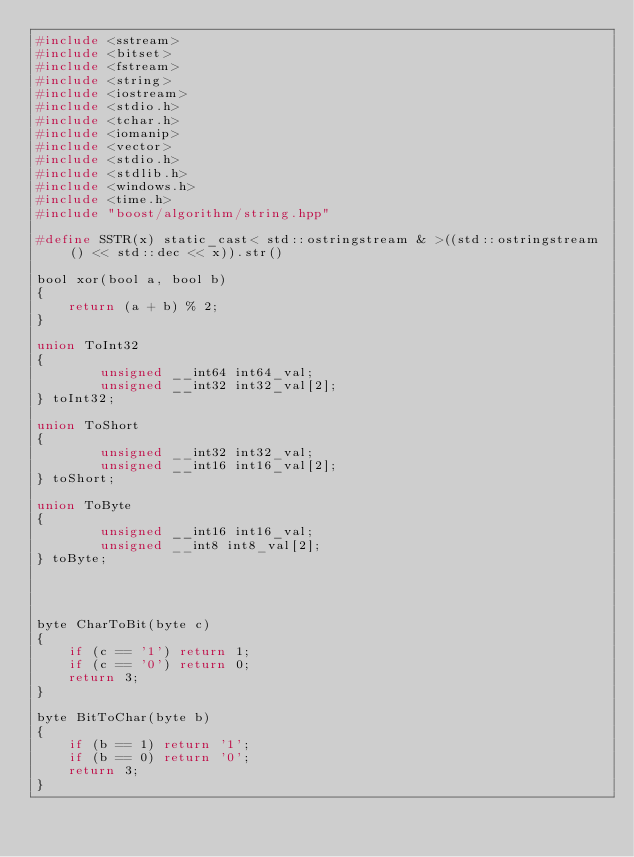<code> <loc_0><loc_0><loc_500><loc_500><_C_>#include <sstream>
#include <bitset>
#include <fstream>
#include <string>
#include <iostream>
#include <stdio.h>
#include <tchar.h>
#include <iomanip>
#include <vector>
#include <stdio.h>
#include <stdlib.h>
#include <windows.h>
#include <time.h>
#include "boost/algorithm/string.hpp"

#define SSTR(x) static_cast< std::ostringstream & >((std::ostringstream() << std::dec << x)).str()

bool xor(bool a, bool b)
{
	return (a + b) % 2;
}

union ToInt32
{
		unsigned __int64 int64_val;
		unsigned __int32 int32_val[2];
} toInt32;

union ToShort
{
		unsigned __int32 int32_val;
		unsigned __int16 int16_val[2];
} toShort;

union ToByte
{
		unsigned __int16 int16_val;
		unsigned __int8 int8_val[2];
} toByte;




byte CharToBit(byte c)
{
	if (c == '1') return 1;
	if (c == '0') return 0;
	return 3;
}

byte BitToChar(byte b)
{
	if (b == 1) return '1';
	if (b == 0) return '0';
	return 3;
}






</code> 